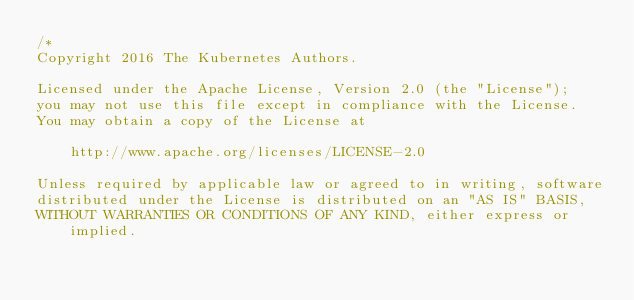<code> <loc_0><loc_0><loc_500><loc_500><_Go_>/*
Copyright 2016 The Kubernetes Authors.

Licensed under the Apache License, Version 2.0 (the "License");
you may not use this file except in compliance with the License.
You may obtain a copy of the License at

    http://www.apache.org/licenses/LICENSE-2.0

Unless required by applicable law or agreed to in writing, software
distributed under the License is distributed on an "AS IS" BASIS,
WITHOUT WARRANTIES OR CONDITIONS OF ANY KIND, either express or implied.</code> 